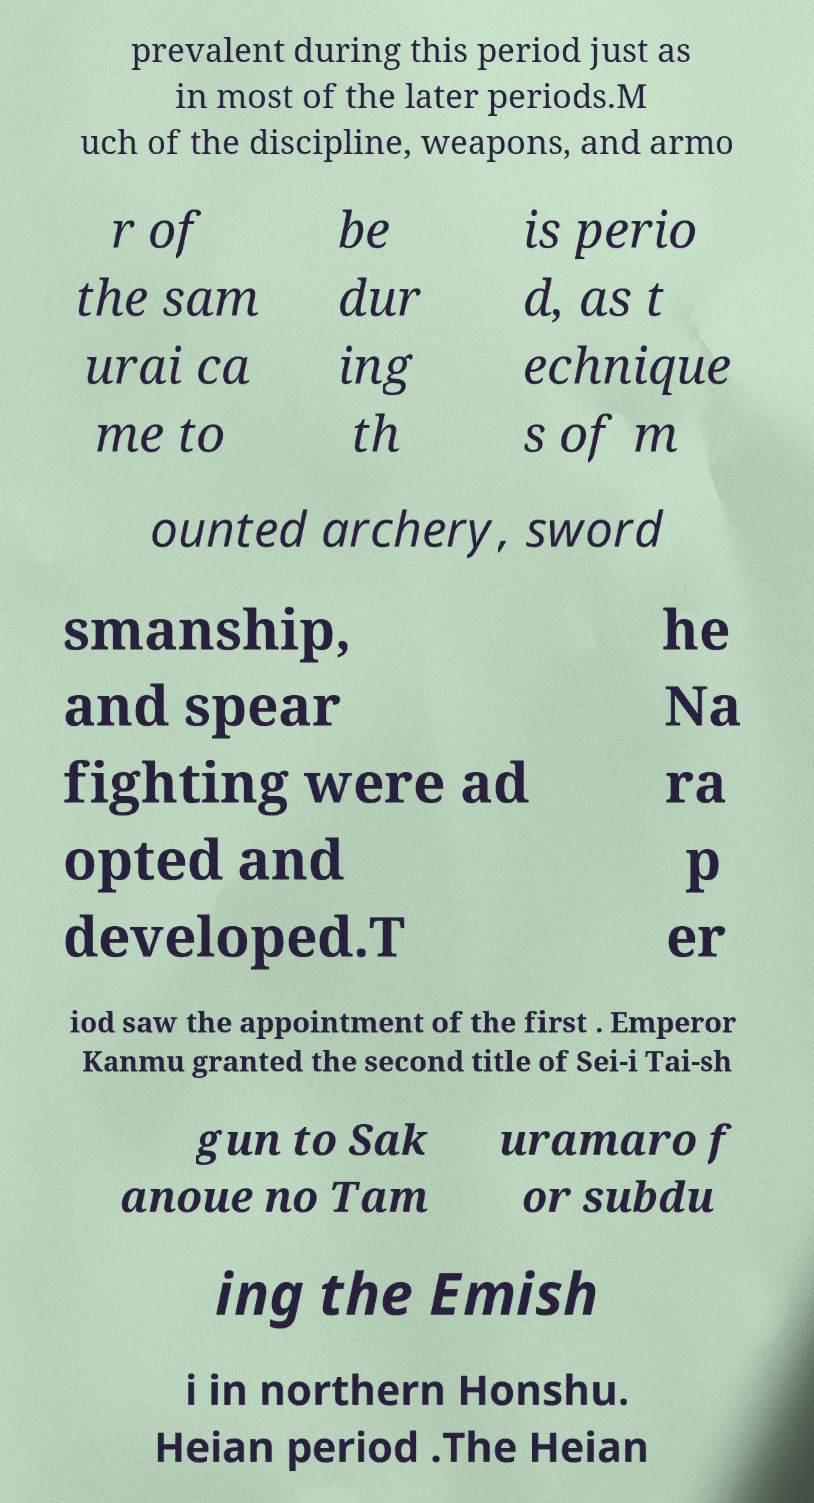Could you extract and type out the text from this image? prevalent during this period just as in most of the later periods.M uch of the discipline, weapons, and armo r of the sam urai ca me to be dur ing th is perio d, as t echnique s of m ounted archery, sword smanship, and spear fighting were ad opted and developed.T he Na ra p er iod saw the appointment of the first . Emperor Kanmu granted the second title of Sei-i Tai-sh gun to Sak anoue no Tam uramaro f or subdu ing the Emish i in northern Honshu. Heian period .The Heian 